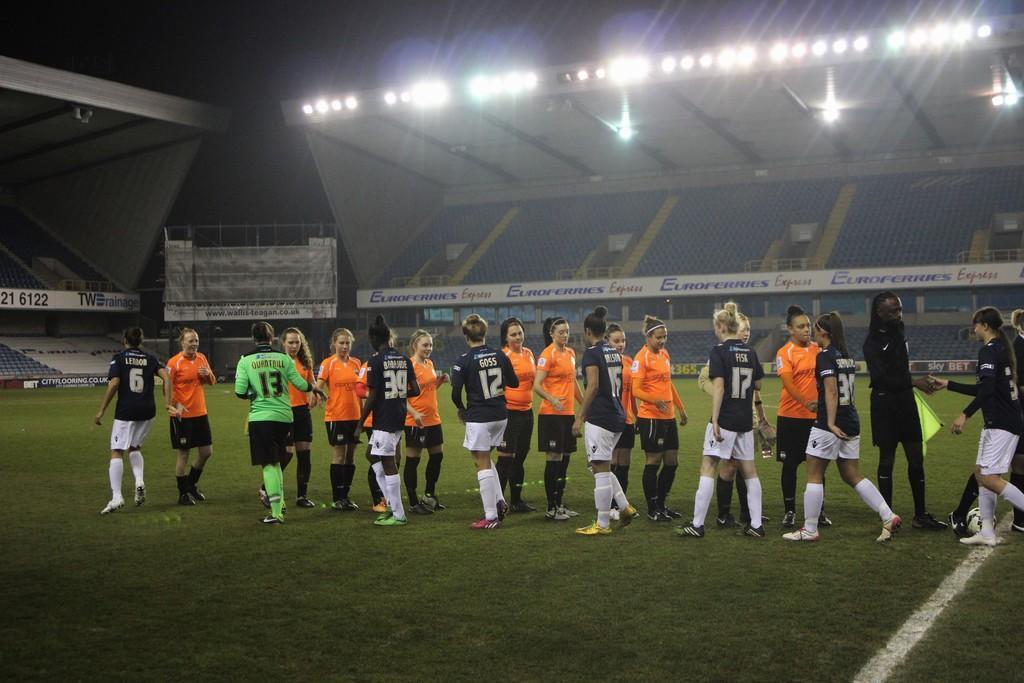Could you give a brief overview of what you see in this image? In the center of the image there are people. At the bottom of the image there is grass. In the background of the image there are stands. At the top of the image there are lights. 